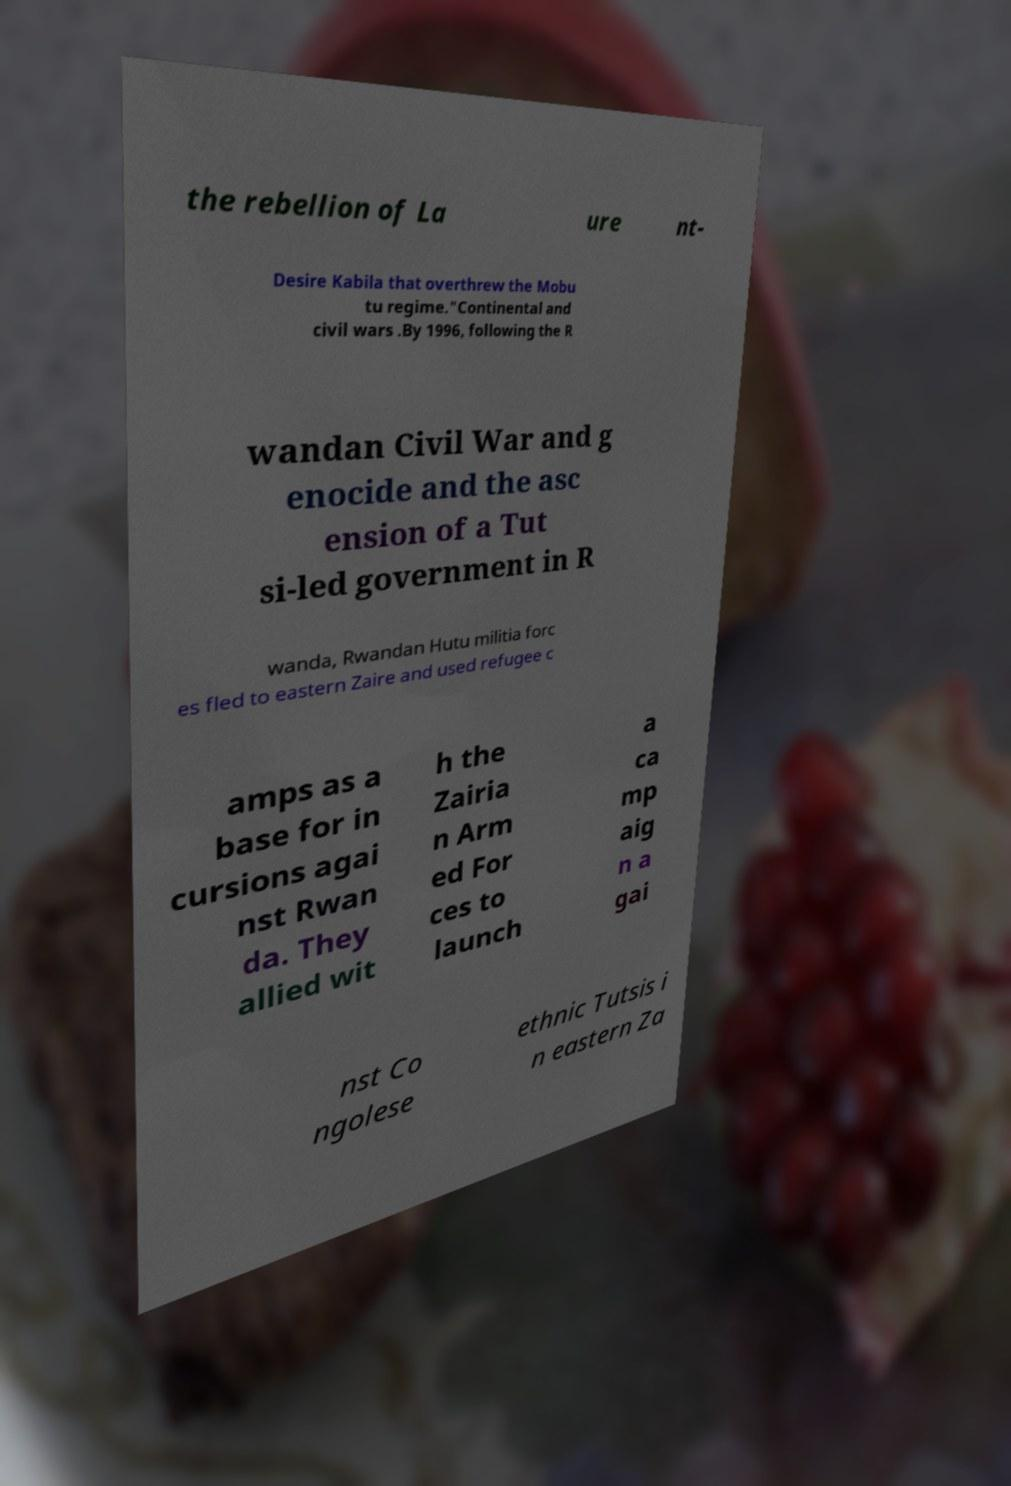I need the written content from this picture converted into text. Can you do that? the rebellion of La ure nt- Desire Kabila that overthrew the Mobu tu regime."Continental and civil wars .By 1996, following the R wandan Civil War and g enocide and the asc ension of a Tut si-led government in R wanda, Rwandan Hutu militia forc es fled to eastern Zaire and used refugee c amps as a base for in cursions agai nst Rwan da. They allied wit h the Zairia n Arm ed For ces to launch a ca mp aig n a gai nst Co ngolese ethnic Tutsis i n eastern Za 